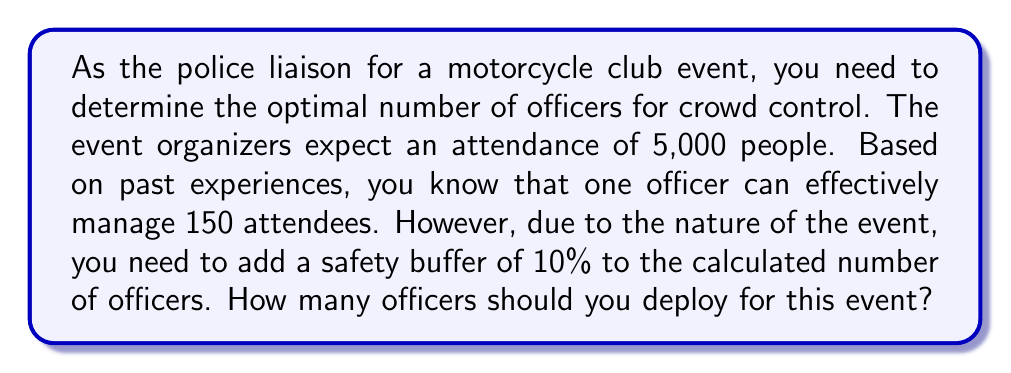What is the answer to this math problem? Let's approach this problem step-by-step:

1) First, we need to calculate the base number of officers needed without the safety buffer:
   
   $$ \text{Base number of officers} = \frac{\text{Total attendees}}{\text{Attendees per officer}} $$
   
   $$ \text{Base number of officers} = \frac{5000}{150} = 33.33 $$

2) Since we can't have a fractional number of officers, we round up to the nearest whole number:
   
   $$ \text{Rounded base number} = \lceil 33.33 \rceil = 34 $$

3) Now, we need to add the 10% safety buffer. To do this, we multiply the rounded base number by 1.1:
   
   $$ \text{Officers with buffer} = 34 \times 1.1 = 37.4 $$

4) Again, we round up to the nearest whole number:
   
   $$ \text{Final number of officers} = \lceil 37.4 \rceil = 38 $$

Therefore, you should deploy 38 officers for this event.
Answer: 38 officers 